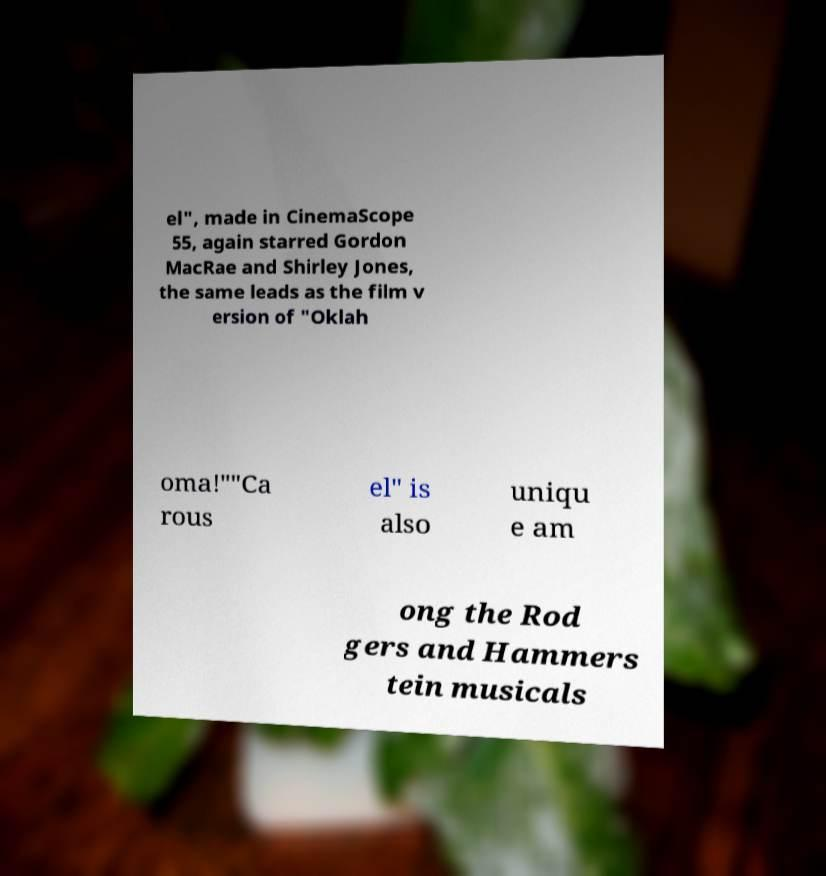Could you assist in decoding the text presented in this image and type it out clearly? el", made in CinemaScope 55, again starred Gordon MacRae and Shirley Jones, the same leads as the film v ersion of "Oklah oma!""Ca rous el" is also uniqu e am ong the Rod gers and Hammers tein musicals 